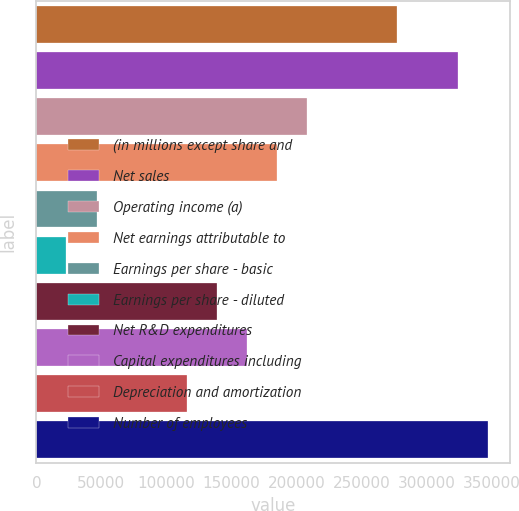<chart> <loc_0><loc_0><loc_500><loc_500><bar_chart><fcel>(in millions except share and<fcel>Net sales<fcel>Operating income (a)<fcel>Net earnings attributable to<fcel>Earnings per share - basic<fcel>Earnings per share - diluted<fcel>Net R&D expenditures<fcel>Capital expenditures including<fcel>Depreciation and amortization<fcel>Number of employees<nl><fcel>277604<fcel>323872<fcel>208203<fcel>185070<fcel>46267.6<fcel>23133.9<fcel>138802<fcel>161936<fcel>115669<fcel>347005<nl></chart> 